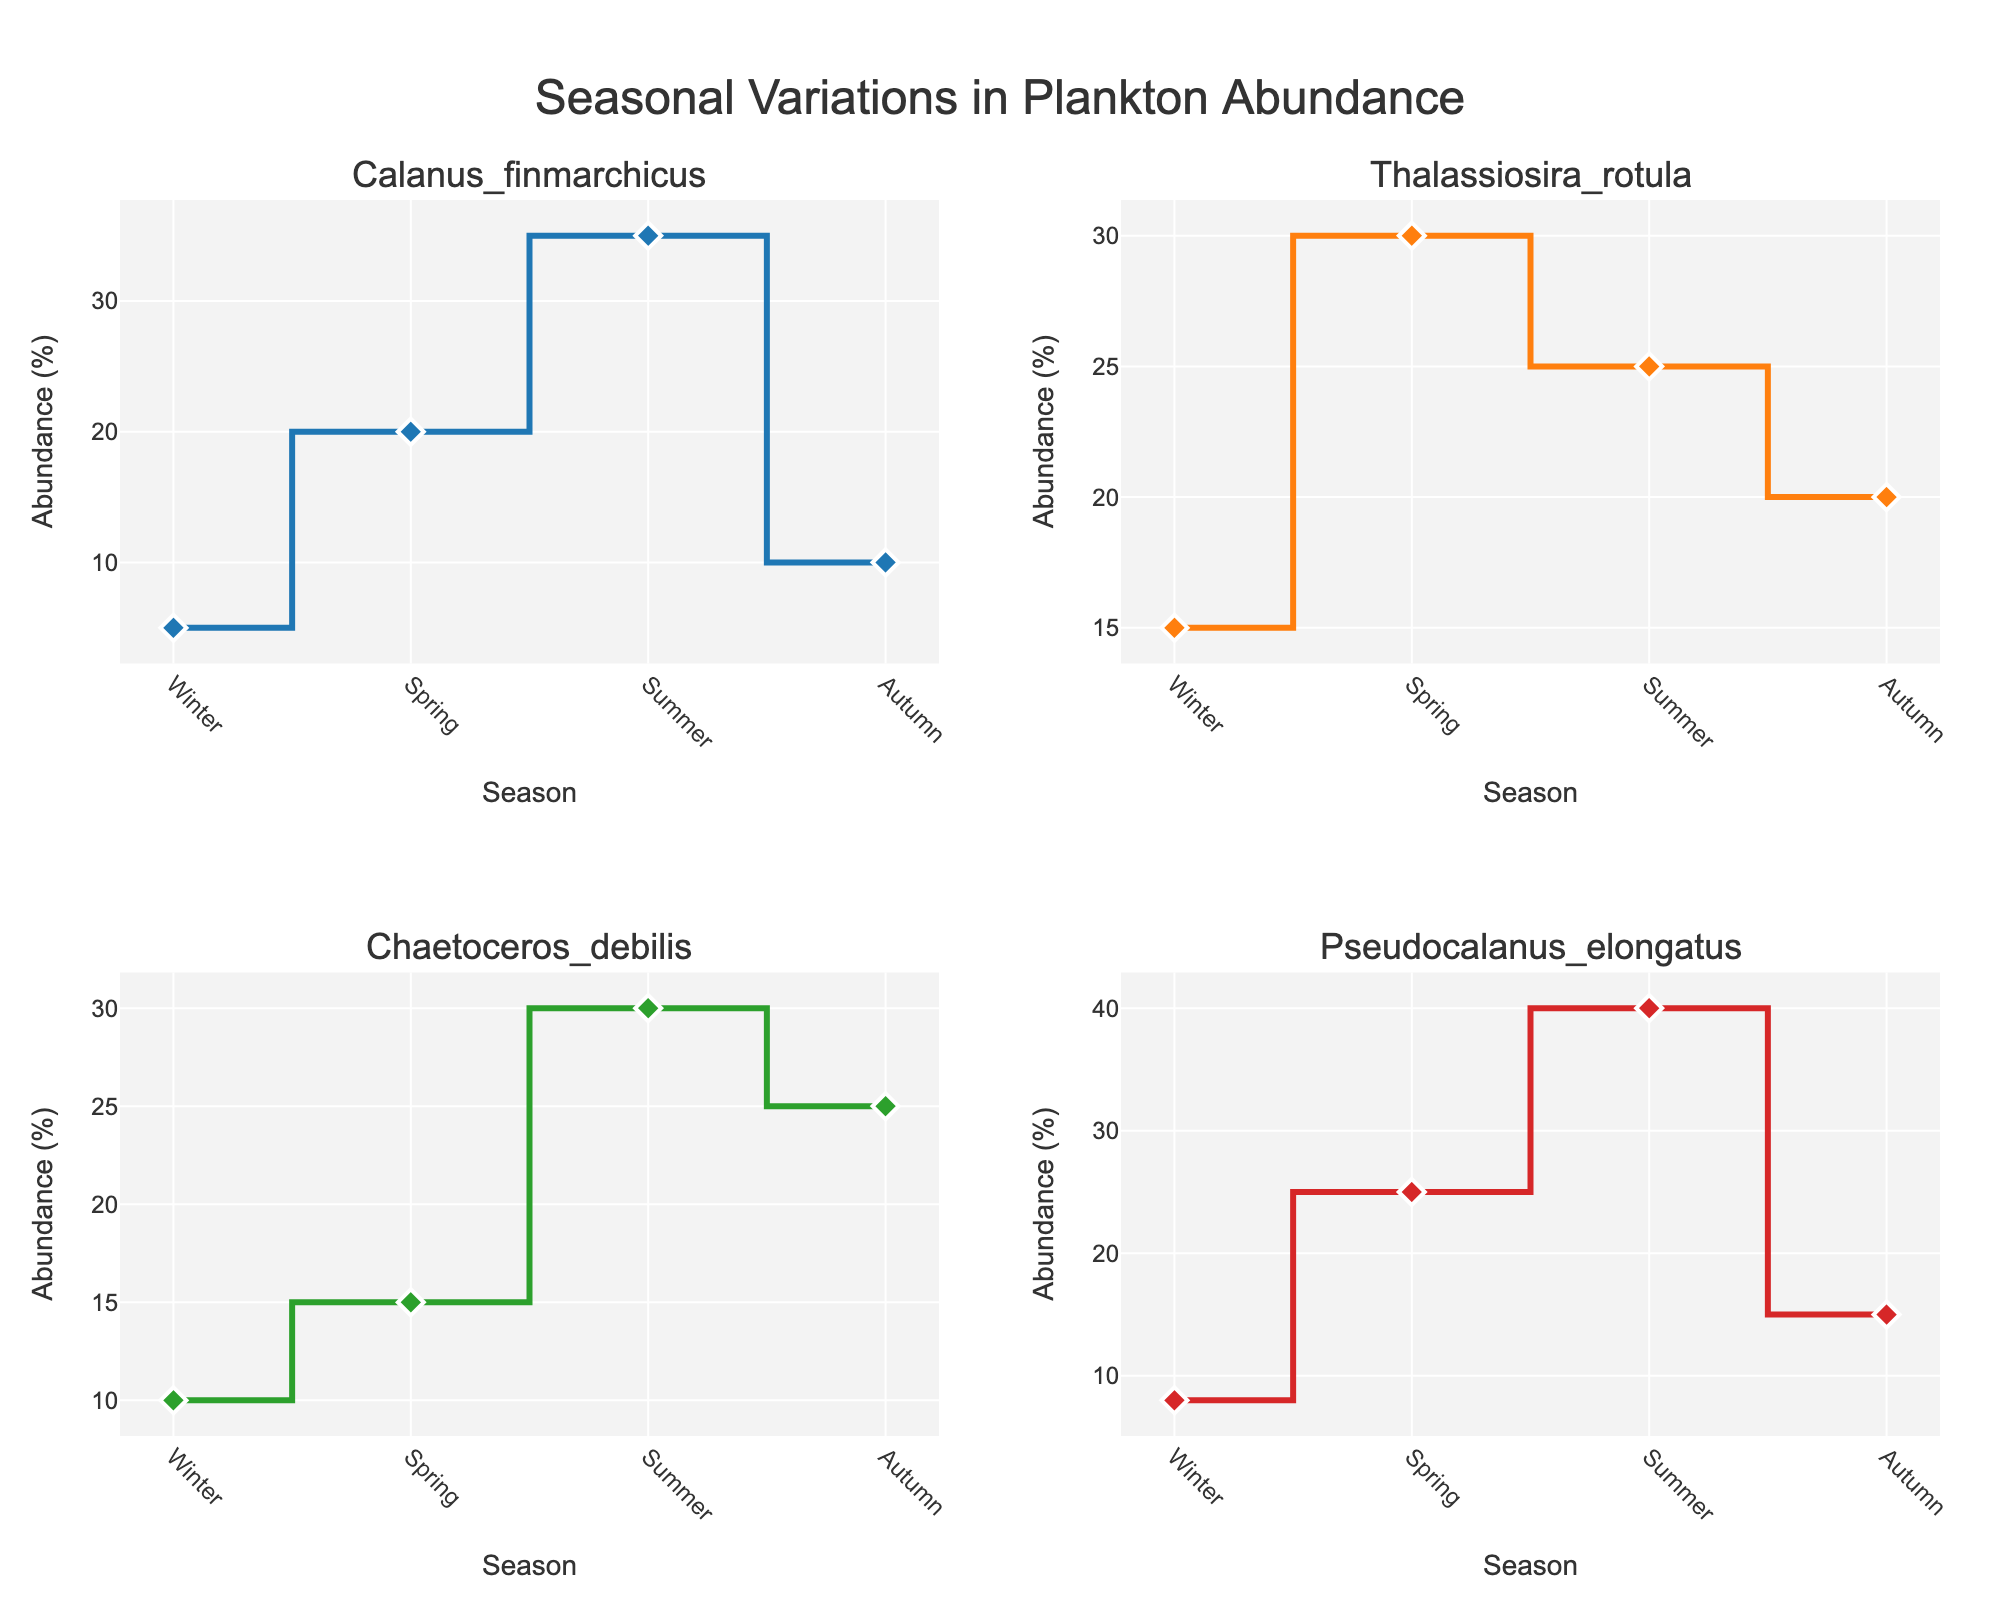What are the titles of the four subplots? The subplot titles are listed at the top of each subplot. They represent the four plankton species: Calanus finmarchicus, Thalassiosira rotula, Chaetoceros debilis, and Pseudocalanus elongatus.
Answer: Calanus finmarchicus, Thalassiosira rotula, Chaetoceros debilis, Pseudocalanus elongatus Which species has the highest abundance percentage in summer? Check the abundance percentages for each species in summer from their respective subplots. Pseudocalanus elongatus has the highest value at 40%.
Answer: Pseudocalanus elongatus During which season does Calanus finmarchicus have the lowest abundance? Refer to the subplot for Calanus finmarchicus and find the smallest value. The lowest abundance is in winter at 5%.
Answer: Winter What is the difference between the highest and lowest abundance percentages of Thalassiosira rotula? Inspect the Thalassiosira rotula subplot. The highest value is 30% in spring, and the lowest value is 15% in winter. The difference is 30% - 15% = 15%.
Answer: 15% Did any species have a consistent increase in abundance from winter to summer? Examine each subplot to see if abundance percentages increase from winter to summer without any decrease in between. None of the species have a consistent increase from winter to summer.
Answer: None Which species has the most significant drop in abundance from summer to autumn? Look at the data points from summer to autumn on each subplot. Calanus finmarchicus drops from 35% to 10%, which is a 25% decrease, the largest observed.
Answer: Calanus finmarchicus What is the combined abundance percentage of all species in spring? Add the spring abundances from each subplot: Calanus finmarchicus (20%), Thalassiosira rotula (30%), Chaetoceros debilis (15%), Pseudocalanus elongatus (25%). The total is 20% + 30% + 15% + 25% = 90%.
Answer: 90% Which season has the highest overall abundance across all species? Sum the abundance percentages across all species for each season and compare. Spring has the highest combined total of 90%.
Answer: Spring 